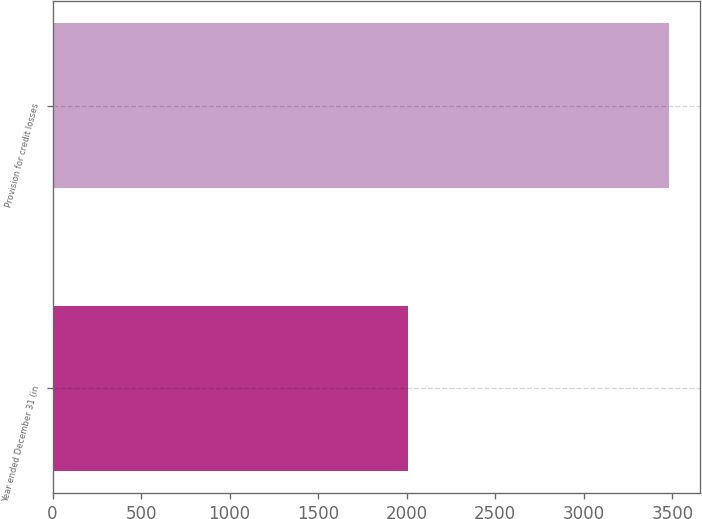Convert chart. <chart><loc_0><loc_0><loc_500><loc_500><bar_chart><fcel>Year ended December 31 (in<fcel>Provision for credit losses<nl><fcel>2005<fcel>3483<nl></chart> 